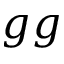Convert formula to latex. <formula><loc_0><loc_0><loc_500><loc_500>g g</formula> 